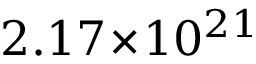<formula> <loc_0><loc_0><loc_500><loc_500>2 . 1 7 \, \times \, 1 0 ^ { 2 1 }</formula> 